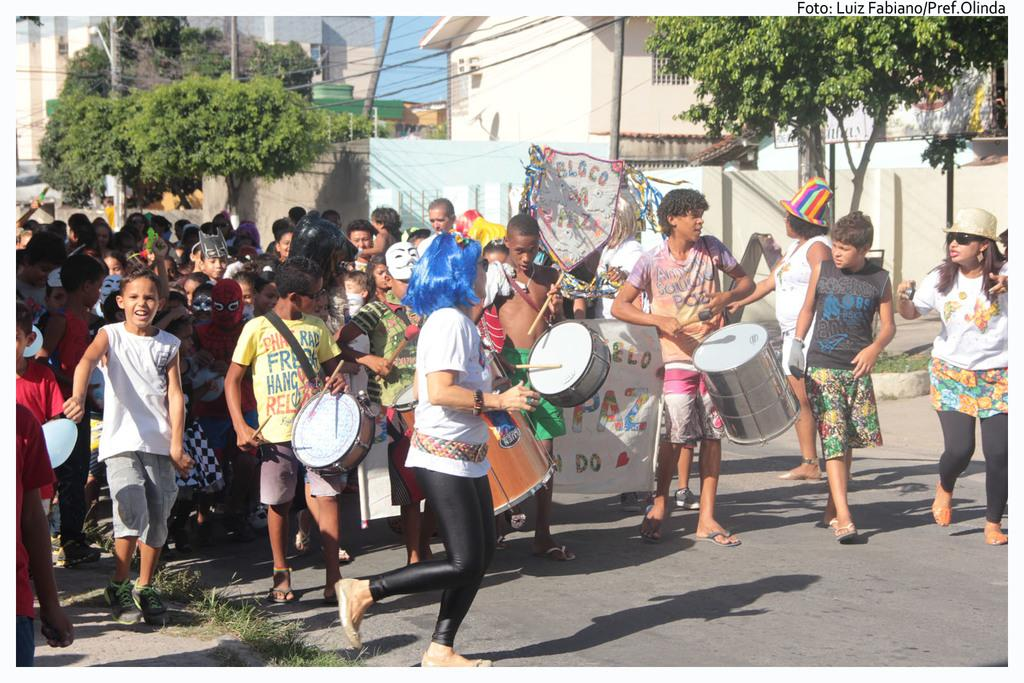What are the children in the image doing? The children in the image are playing drums. Where are the children located? The children are walking on a road. Are there any other children in the image? Yes, there are other children behind them. What are the children behind them wearing? The children behind them are wearing costumes. What type of currency is being exchanged between the children's toes in the image? There is no exchange of currency or any mention of toes in the image; the children are playing drums and walking on a road. 